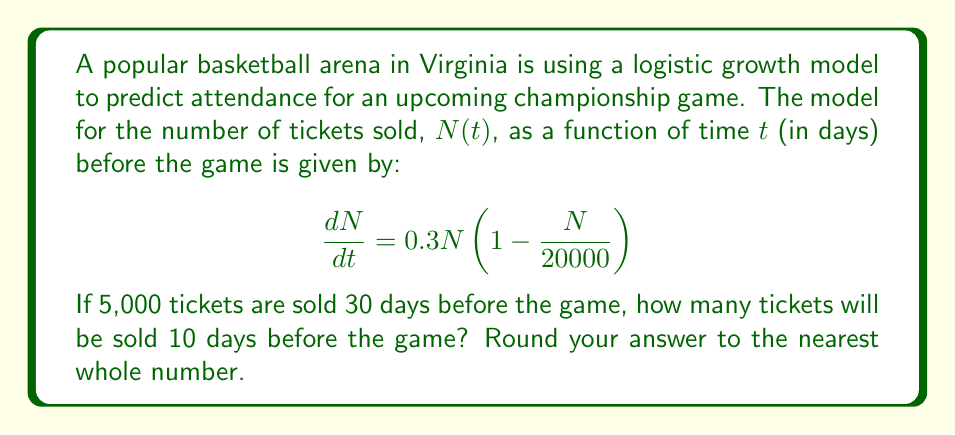Provide a solution to this math problem. To solve this problem, we need to use the logistic growth model and its solution. The general form of the logistic differential equation is:

$$\frac{dN}{dt} = rN\left(1 - \frac{N}{K}\right)$$

where $r$ is the growth rate and $K$ is the carrying capacity.

In our case, $r = 0.3$ and $K = 20000$.

The solution to this differential equation is:

$$N(t) = \frac{K}{1 + \left(\frac{K}{N_0} - 1\right)e^{-rt}}$$

where $N_0$ is the initial population.

Given:
- $N_0 = 5000$ (initial number of tickets sold)
- $t_0 = 30$ days (initial time)
- $t = 20$ days (time elapsed, as we want to know the number 10 days before the game)

We need to find $N(20)$.

First, let's calculate $\left(\frac{K}{N_0} - 1\right)$:

$$\left(\frac{20000}{5000} - 1\right) = 3$$

Now, we can plug all the values into the solution equation:

$$N(20) = \frac{20000}{1 + 3e^{-0.3(20)}}$$

$$N(20) = \frac{20000}{1 + 3e^{-6}}$$

$$N(20) = \frac{20000}{1 + 3(0.00247875)}$$

$$N(20) = \frac{20000}{1.00743625}$$

$$N(20) = 19852.47$$

Rounding to the nearest whole number, we get 19,852 tickets.
Answer: 19,852 tickets 